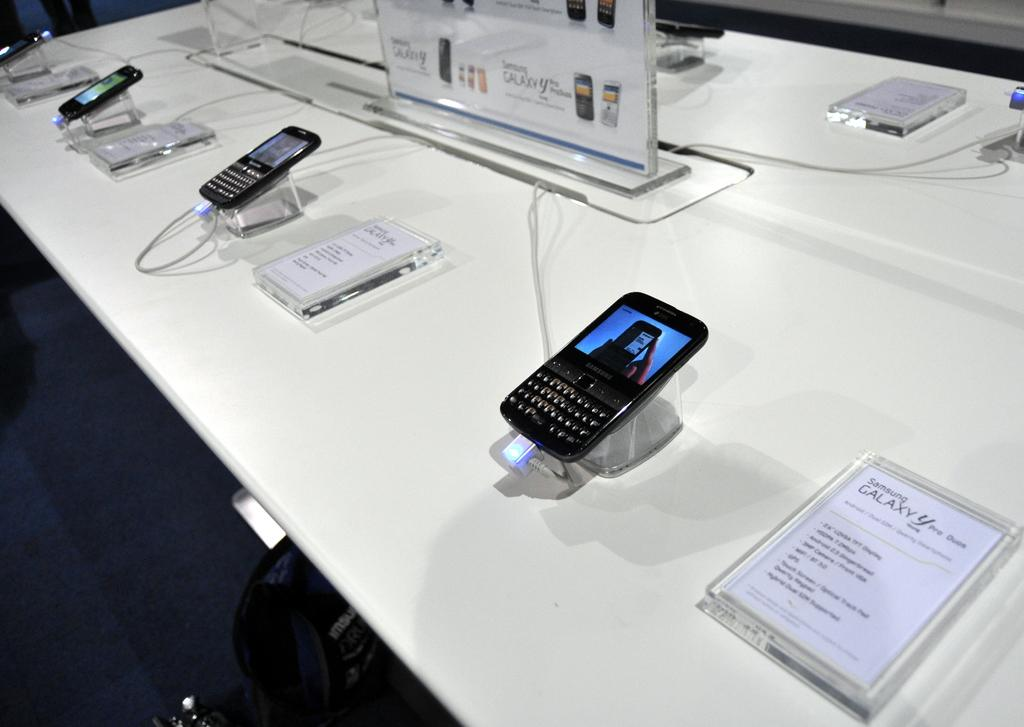<image>
Write a terse but informative summary of the picture. A row of Samsung Galaxy Phones are on display in a store 